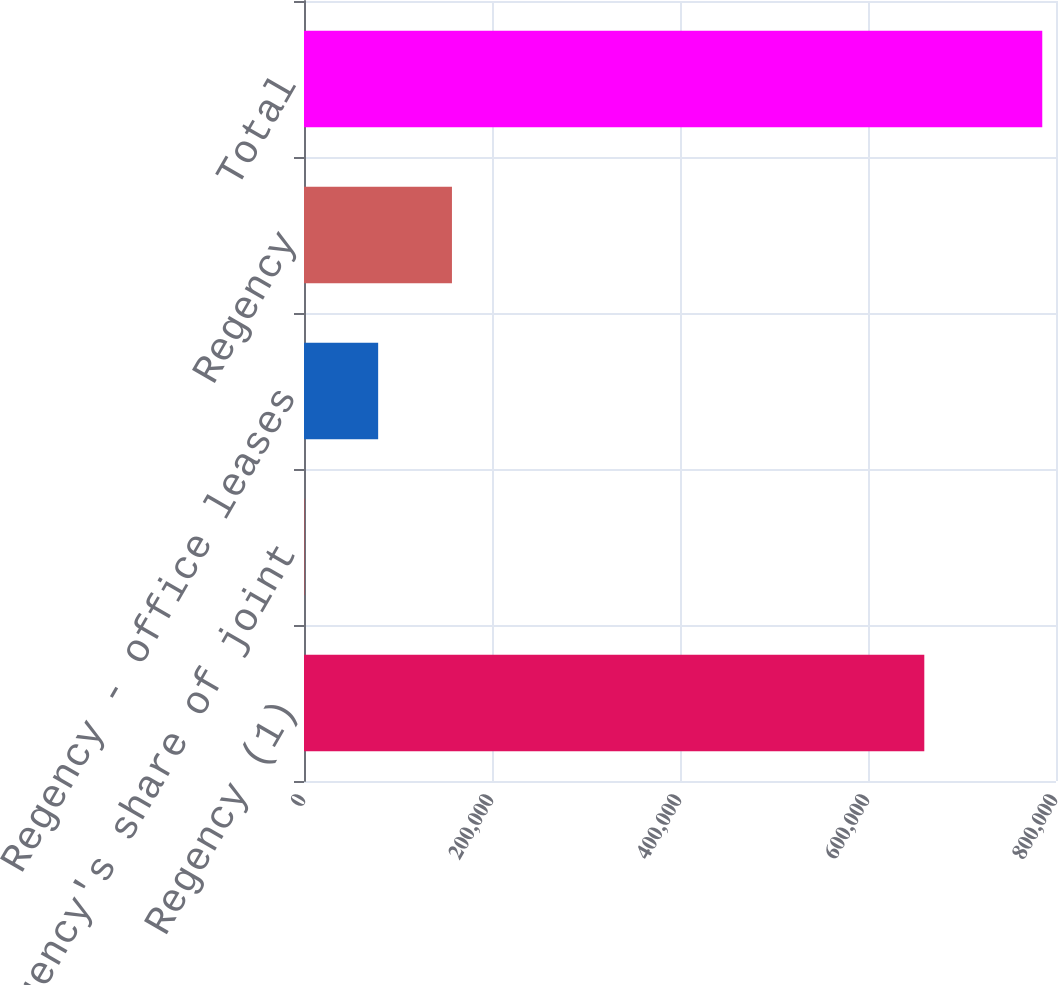Convert chart to OTSL. <chart><loc_0><loc_0><loc_500><loc_500><bar_chart><fcel>Regency (1)<fcel>Regency's share of joint<fcel>Regency - office leases<fcel>Regency<fcel>Total<nl><fcel>659897<fcel>392<fcel>78892.1<fcel>157392<fcel>785393<nl></chart> 